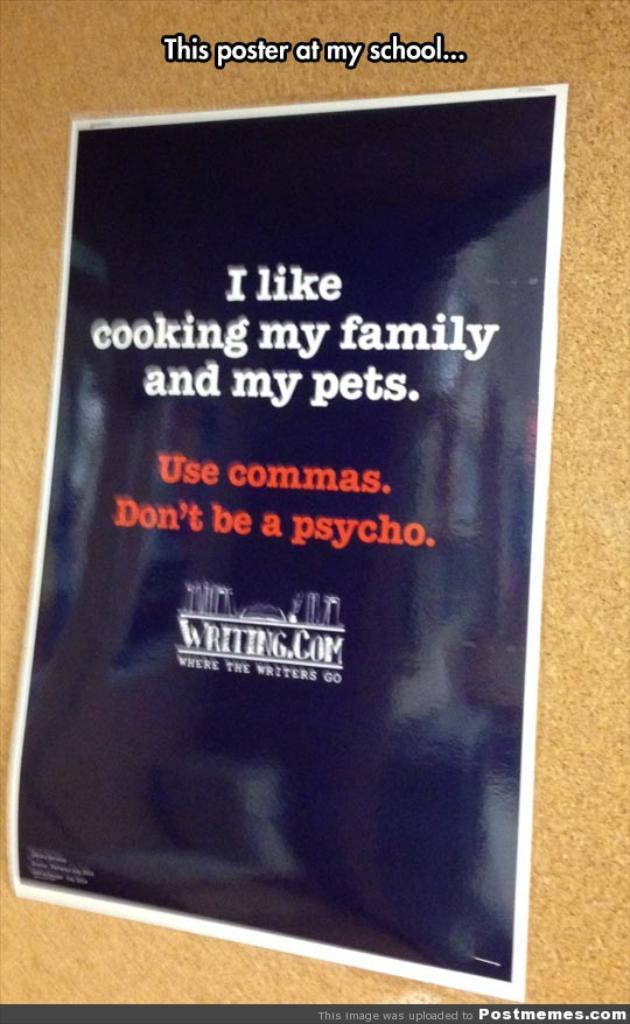<image>
Present a compact description of the photo's key features. A black and white poster with red and white letters from Writting.com. 